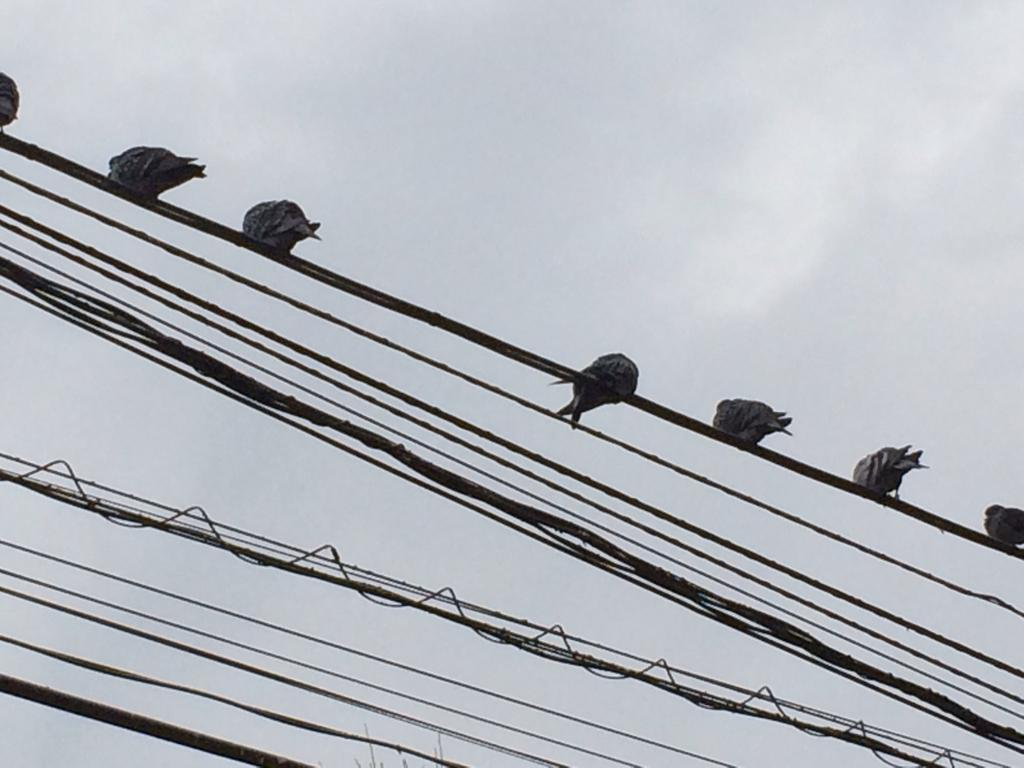What can be seen in the image that is related to electricity or communication? There are wires in the image. Are there any living creatures on the wires? Yes, some wires have birds on them. What can be seen in the background of the image? There are clouds and the sky visible in the background. Where is the dustbin located in the image? There is no dustbin present in the image. Can you see a yak in the image? No, there are no yaks present in the image. 